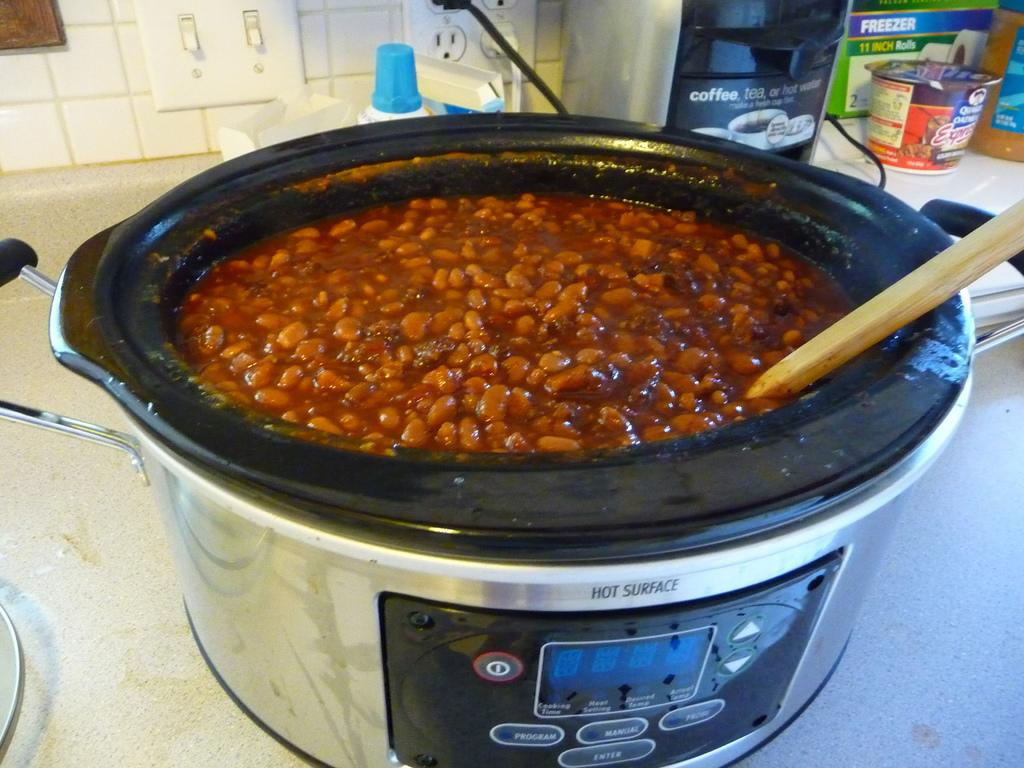<image>
Summarize the visual content of the image. the crock pot has a hot surface warning non the top of it 